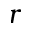Convert formula to latex. <formula><loc_0><loc_0><loc_500><loc_500>r</formula> 